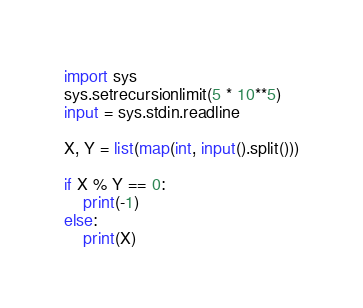<code> <loc_0><loc_0><loc_500><loc_500><_Python_>import sys
sys.setrecursionlimit(5 * 10**5)
input = sys.stdin.readline

X, Y = list(map(int, input().split()))

if X % Y == 0:
    print(-1)
else:
    print(X)

</code> 